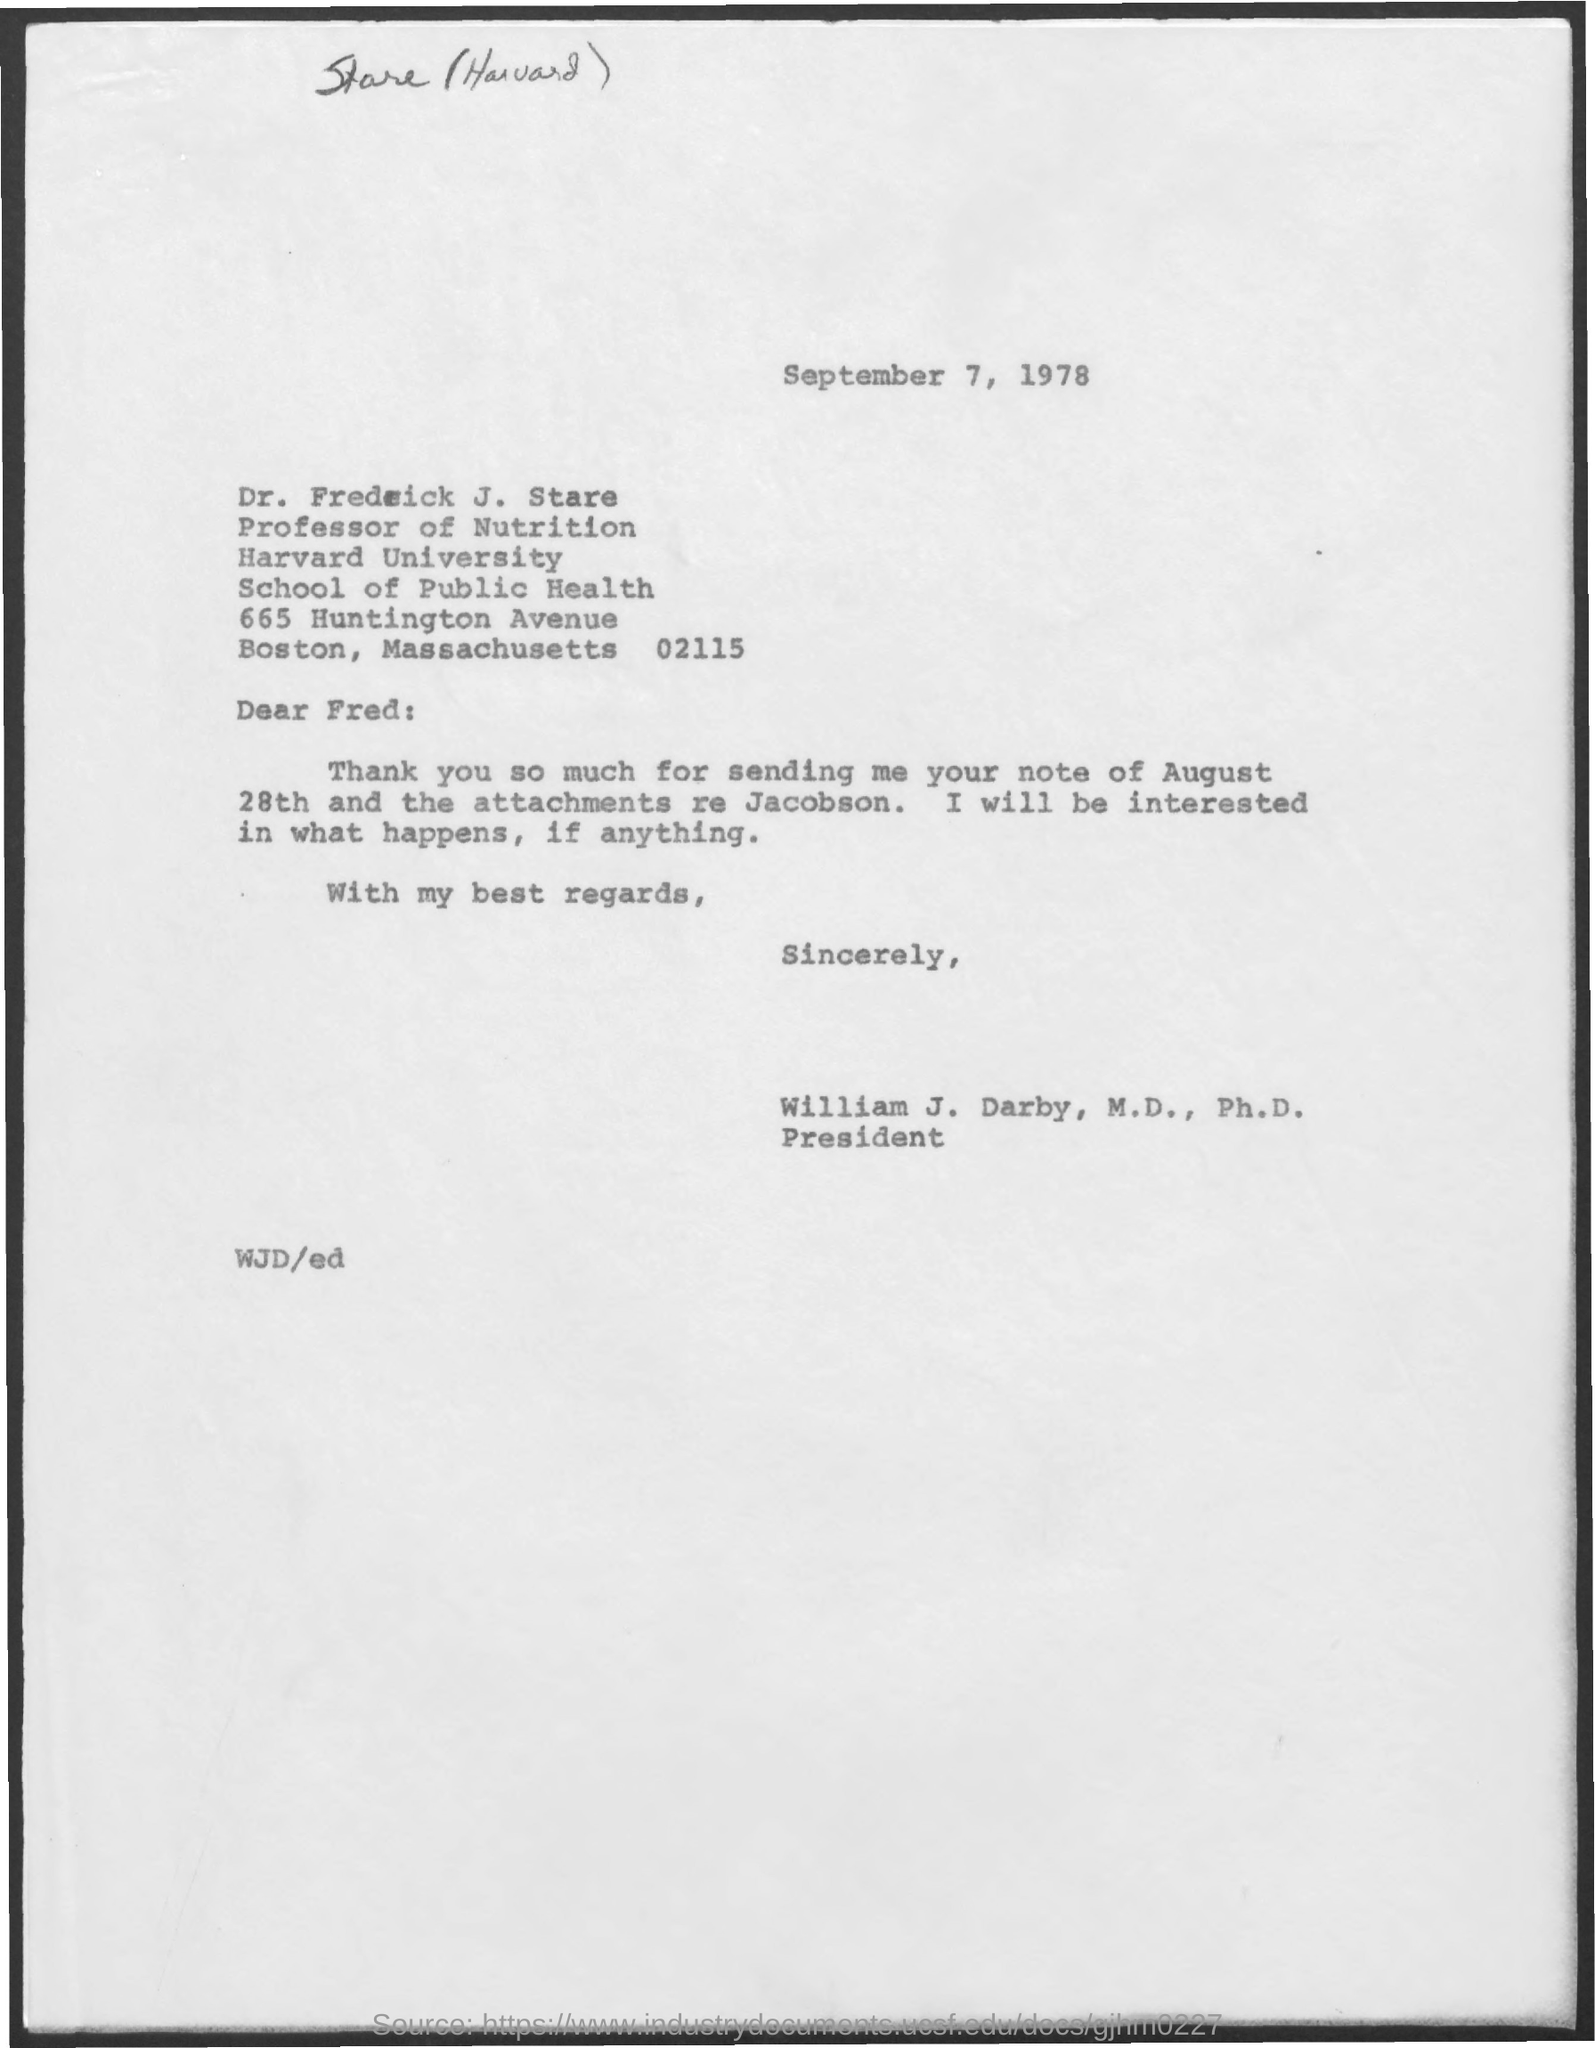What is the date mentioned in the given page ?
Provide a short and direct response. September 7, 1978. What  is the designation of dr. fredrick j. stare ?
Provide a short and direct response. Professor of Nutrition. What is the name of the university mentioned in the given form ?
Your answer should be very brief. Harvard university. What is the designation of william j darby mentioned ?
Offer a terse response. President. To whom the letter was sent ?
Provide a succinct answer. Fred. 